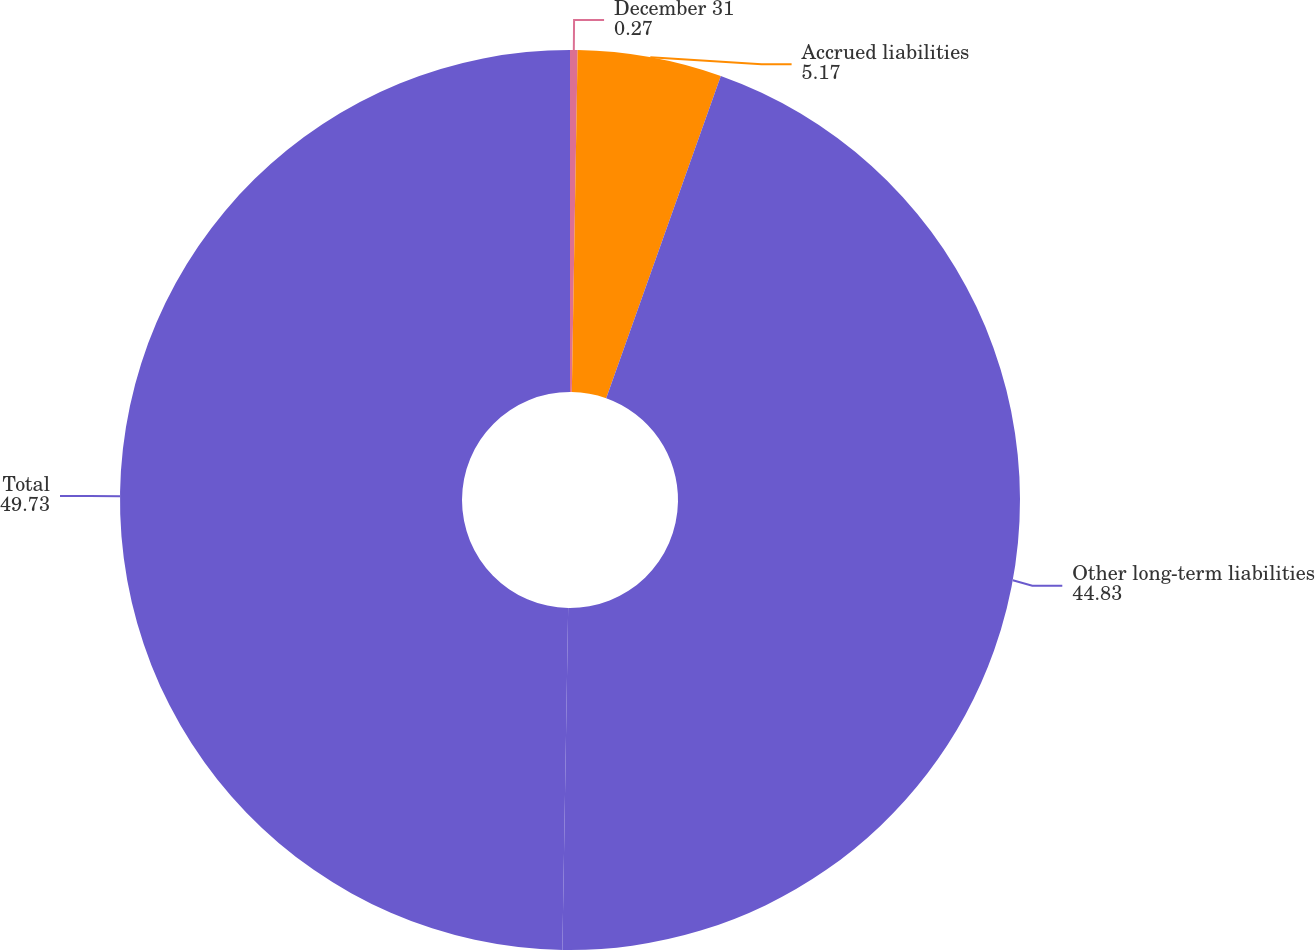Convert chart. <chart><loc_0><loc_0><loc_500><loc_500><pie_chart><fcel>December 31<fcel>Accrued liabilities<fcel>Other long-term liabilities<fcel>Total<nl><fcel>0.27%<fcel>5.17%<fcel>44.83%<fcel>49.73%<nl></chart> 